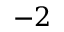<formula> <loc_0><loc_0><loc_500><loc_500>- 2</formula> 